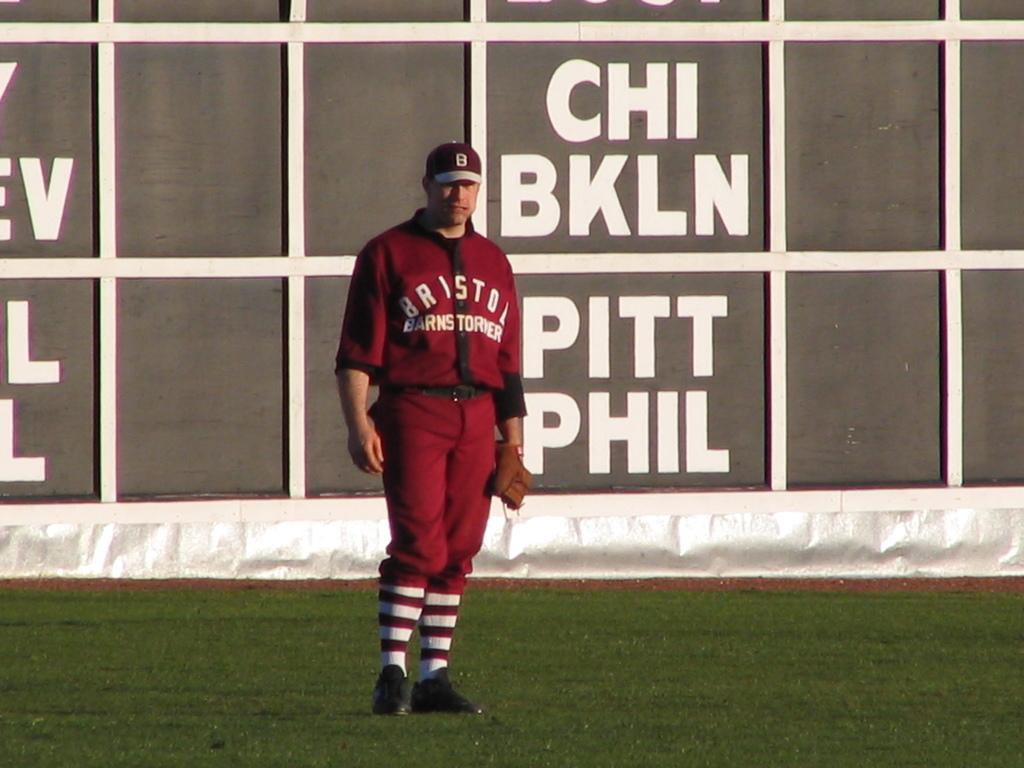What's the name on the jersey?
Ensure brevity in your answer.  Bristol. What name is on the bottom right?
Give a very brief answer. Phil. 